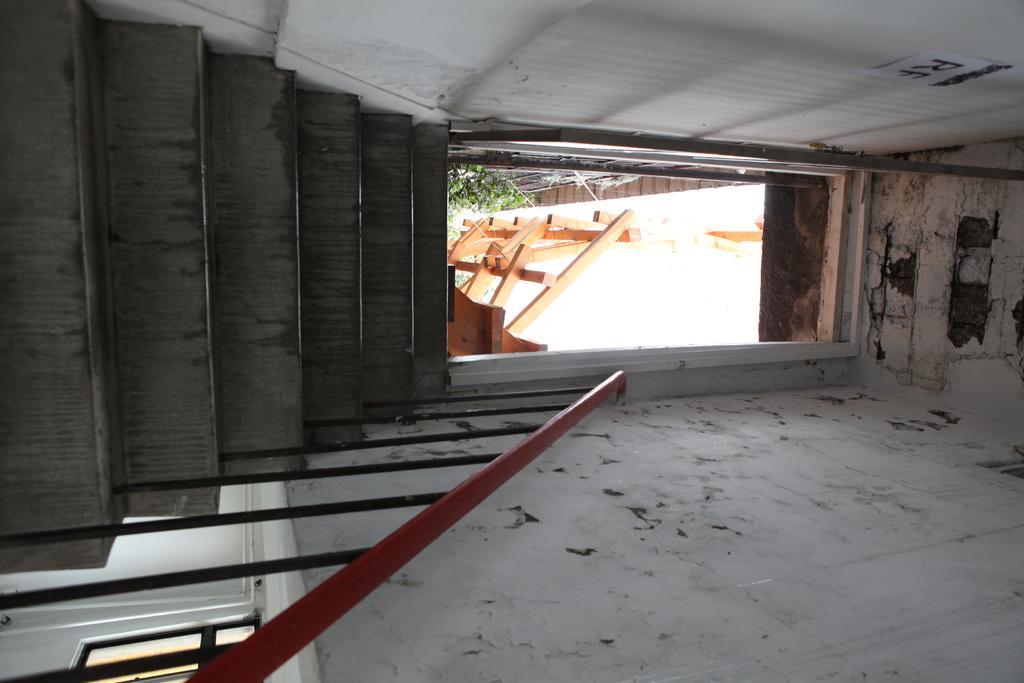Could you give a brief overview of what you see in this image? In this image we can see stairs, railing, door and walls. 